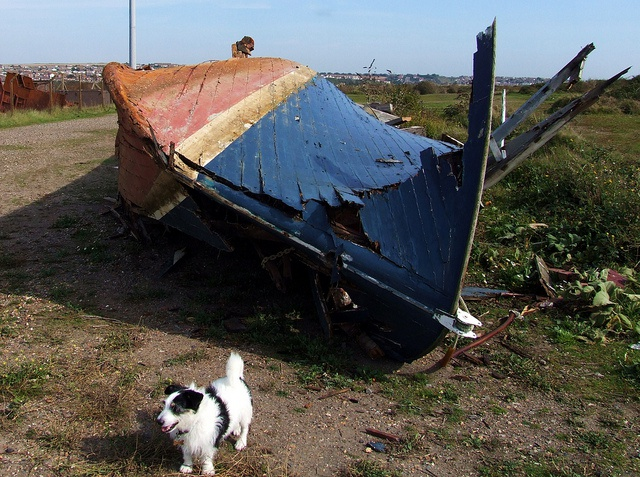Describe the objects in this image and their specific colors. I can see boat in lavender, black, gray, navy, and tan tones and dog in lavender, white, black, darkgray, and gray tones in this image. 